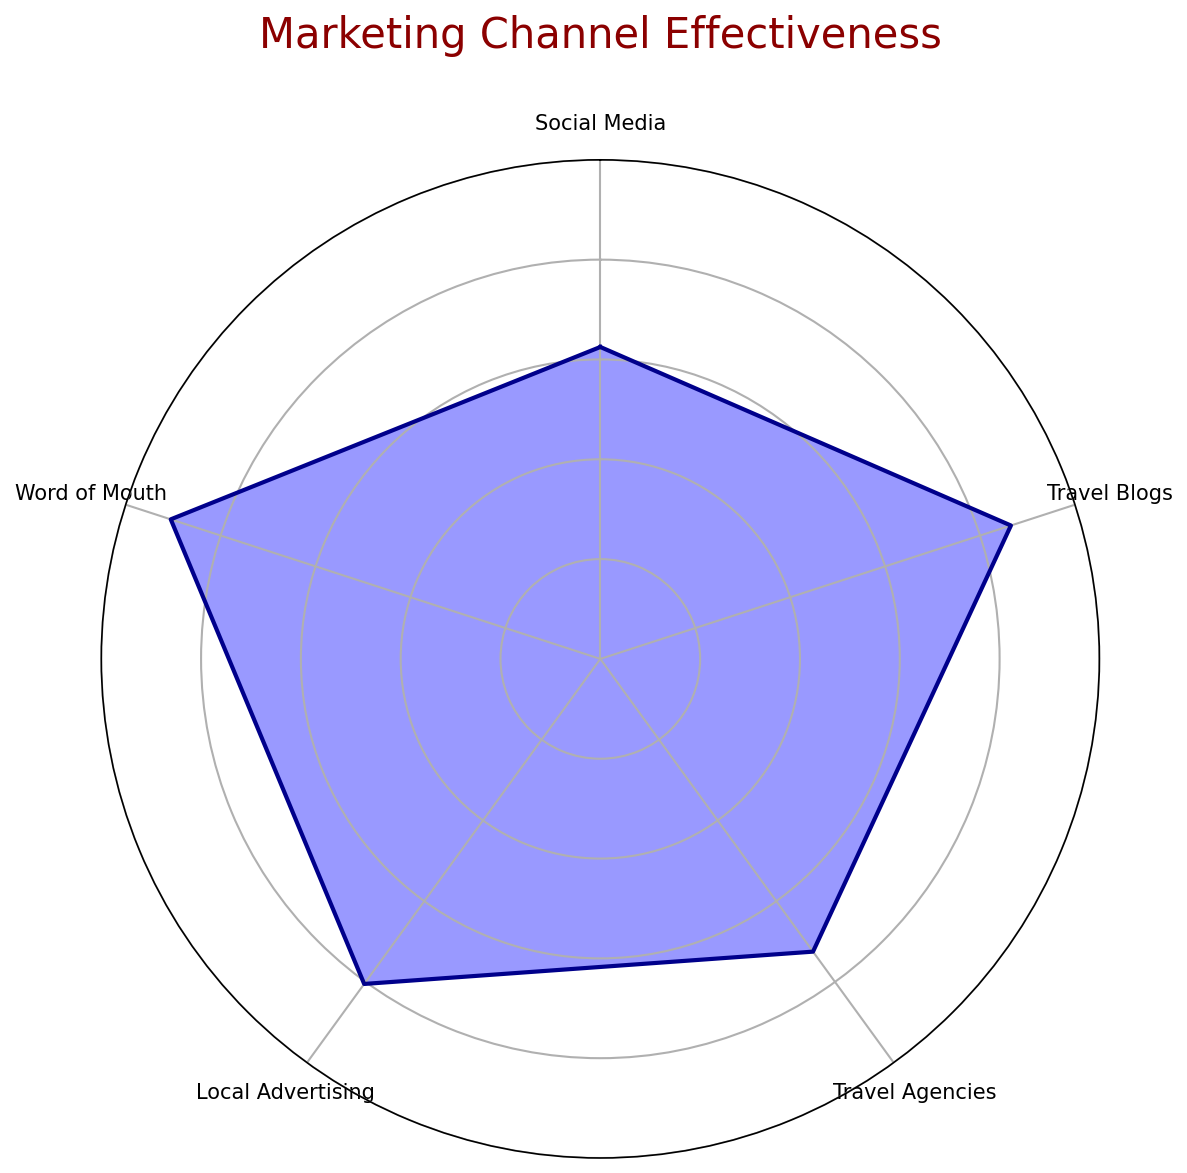What is the most effective marketing channel displayed on the radar chart? By examining the radar chart and comparing the different channels, Word of Mouth has the highest effectiveness score.
Answer: Word of Mouth Which marketing channel is the least effective according to the radar chart? The radar chart shows that Local Advertising has the lowest effectiveness score compared to the other channels.
Answer: Local Advertising What is the average effectiveness score of all the marketing channels combined? To find the average effectiveness, sum the effectiveness scores of all channels and divide by the number of channels: (86 + 80.5 + 72.5 + 62.5 + 90.5) / 5 = 78.4.
Answer: 78.4 How does the effectiveness of Social Media compare to that of Travel Blogs? By looking at the radar chart, the effectiveness score of Social Media (86) is slightly higher than that of Travel Blogs (80.5).
Answer: Social Media is higher Which two marketing channels have the closest effectiveness scores? Comparing the scores, Travel Blogs (80.5) and Social Media (86) have relatively close effectiveness scores, but even closer are Travel Agencies (72.5) and Local Advertising (62.5).
Answer: Travel Blogs and Social Media What is the effectiveness difference between the highest and lowest scoring channels? Subtract the effectiveness score of the lowest channel (Local Advertising) from the highest channel (Word of Mouth): 90.5 - 62.5 = 28.
Answer: 28 How would you visually describe the coverage of Word of Mouth on the radar chart? Word of Mouth has the largest coverage area on the radar chart, extending farthest from the center compared to other channels, indicating its highest effectiveness.
Answer: Largest coverage area If you were to rank the marketing channels from most effective to least effective, what would the order be? Based on the radar chart scores: Word of Mouth, Social Media, Travel Blogs, Travel Agencies, Local Advertising.
Answer: Word of Mouth, Social Media, Travel Blogs, Travel Agencies, Local Advertising What is the effectiveness difference between Social Media and Travel Agencies? Subtract the effectiveness score of Travel Agencies from that of Social Media: 86 - 72.5 = 13.5.
Answer: 13.5 Describe the variation in effectiveness scores among all the channels. The variation in the radar chart shows Word of Mouth with the highest score at 90.5, Social Media at 86, Travel Blogs at 80.5, Travel Agencies at 72.5, and Local Advertising at 62.5, indicating a range from 62.5 to 90.5.
Answer: Range from 62.5 to 90.5 